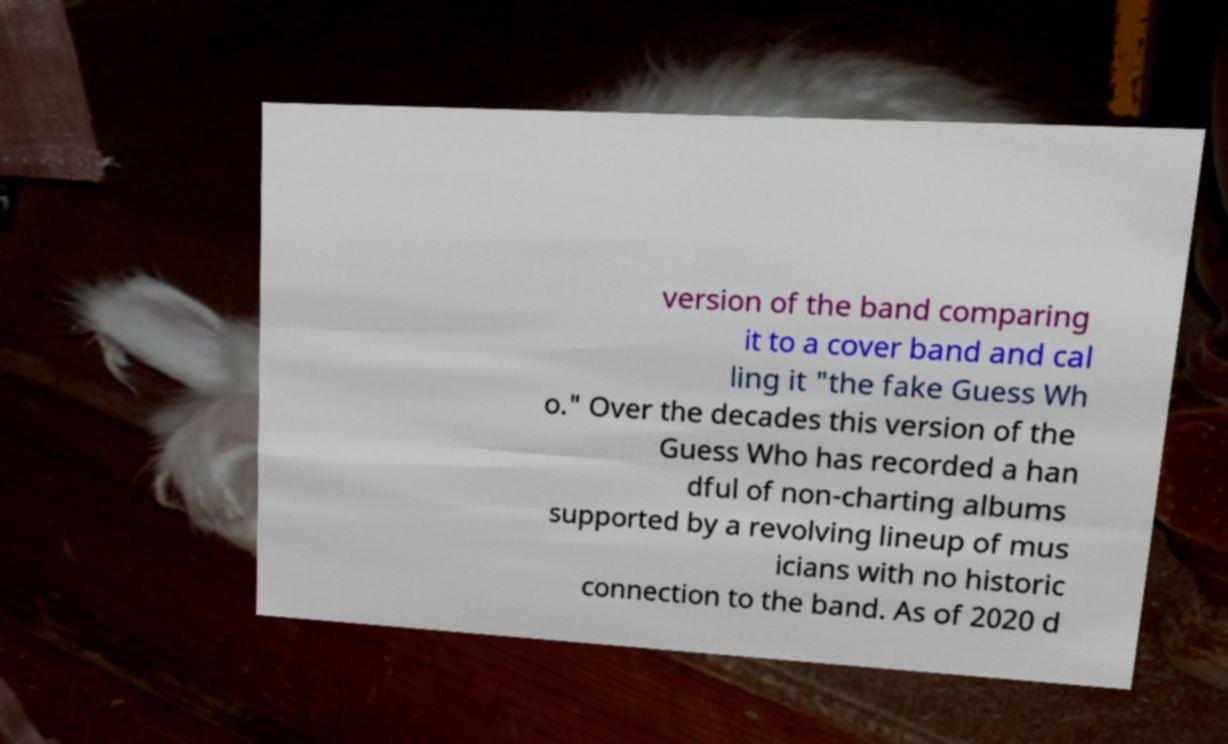There's text embedded in this image that I need extracted. Can you transcribe it verbatim? version of the band comparing it to a cover band and cal ling it "the fake Guess Wh o." Over the decades this version of the Guess Who has recorded a han dful of non-charting albums supported by a revolving lineup of mus icians with no historic connection to the band. As of 2020 d 